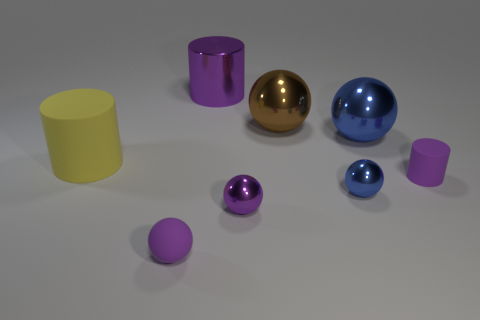There is a large metallic object that is right of the tiny metal thing behind the small purple metallic thing; what color is it? The large metallic object situated to the right of the smaller metal item and behind the small purple metal object is blue. It appears to reflect the light with a smooth, shiny surface indicative of its metallic texture. 